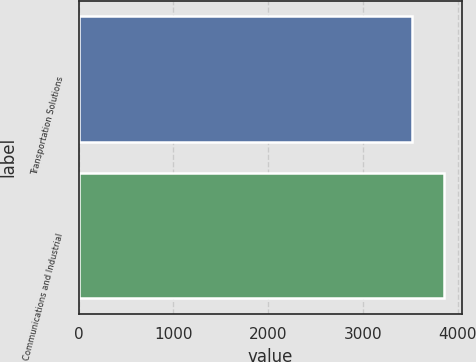<chart> <loc_0><loc_0><loc_500><loc_500><bar_chart><fcel>Transportation Solutions<fcel>Communications and Industrial<nl><fcel>3518<fcel>3858<nl></chart> 